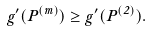<formula> <loc_0><loc_0><loc_500><loc_500>g ^ { \prime } ( P ^ { ( m ) } ) \geq g ^ { \prime } ( P ^ { ( 2 ) } ) .</formula> 